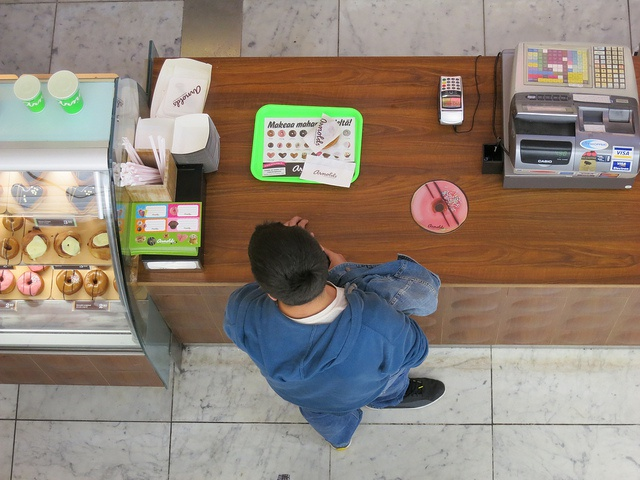Describe the objects in this image and their specific colors. I can see people in gray, blue, and black tones, donut in gray, lightpink, salmon, and brown tones, cup in gray, beige, lightgreen, and aquamarine tones, donut in gray, tan, olive, and khaki tones, and cup in gray, beige, and lightgreen tones in this image. 